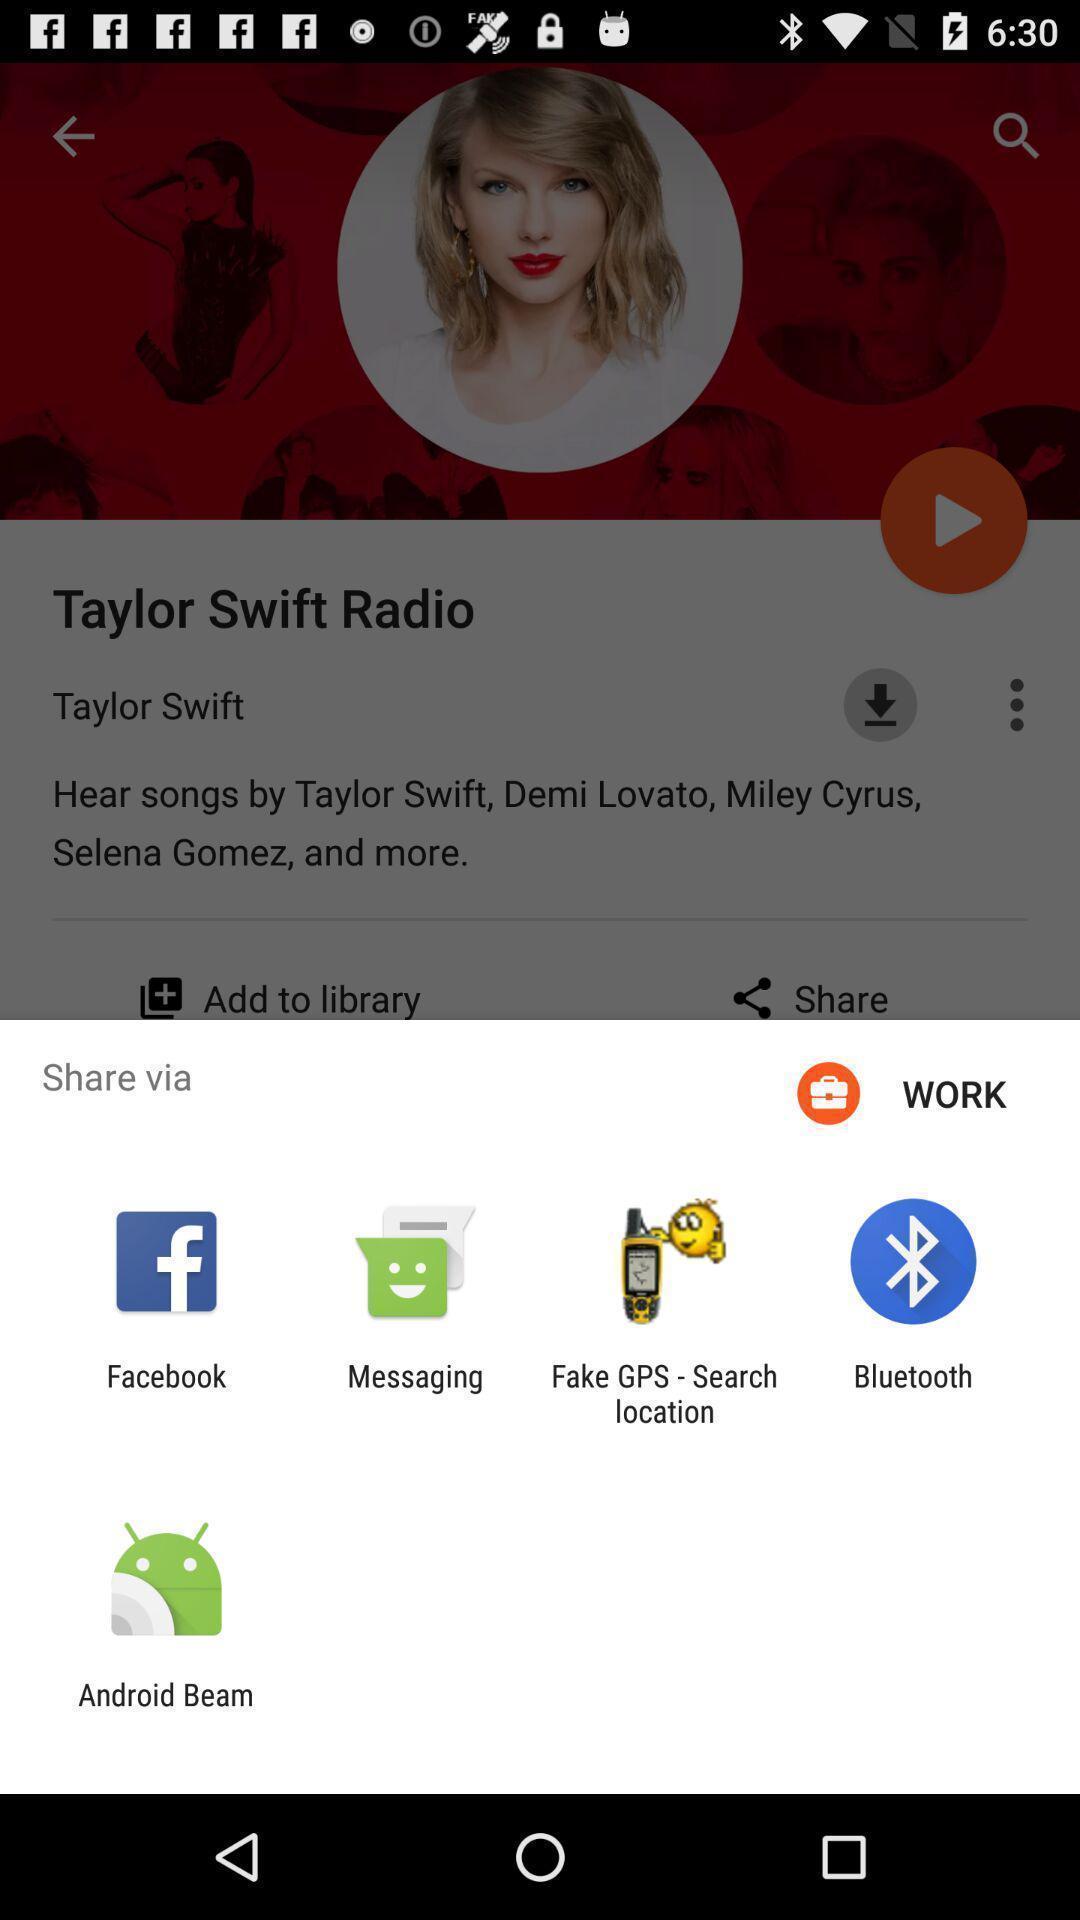Give me a summary of this screen capture. Pop-up displays various apps to share data. 